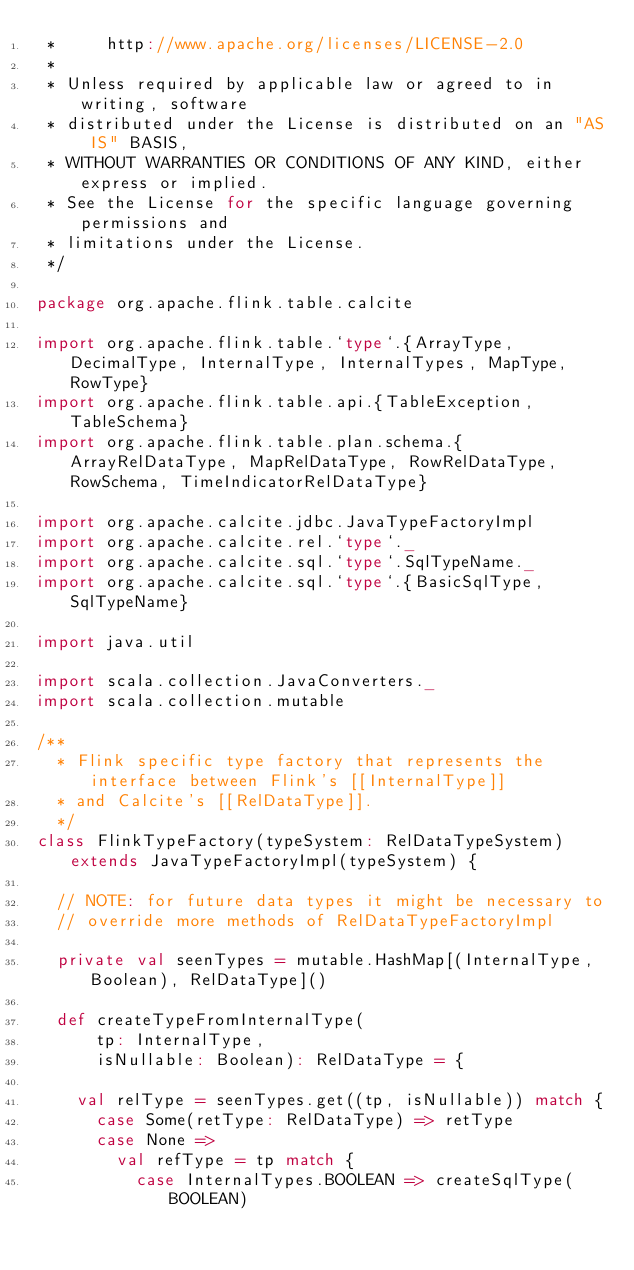<code> <loc_0><loc_0><loc_500><loc_500><_Scala_> *     http://www.apache.org/licenses/LICENSE-2.0
 *
 * Unless required by applicable law or agreed to in writing, software
 * distributed under the License is distributed on an "AS IS" BASIS,
 * WITHOUT WARRANTIES OR CONDITIONS OF ANY KIND, either express or implied.
 * See the License for the specific language governing permissions and
 * limitations under the License.
 */

package org.apache.flink.table.calcite

import org.apache.flink.table.`type`.{ArrayType, DecimalType, InternalType, InternalTypes, MapType, RowType}
import org.apache.flink.table.api.{TableException, TableSchema}
import org.apache.flink.table.plan.schema.{ArrayRelDataType, MapRelDataType, RowRelDataType, RowSchema, TimeIndicatorRelDataType}

import org.apache.calcite.jdbc.JavaTypeFactoryImpl
import org.apache.calcite.rel.`type`._
import org.apache.calcite.sql.`type`.SqlTypeName._
import org.apache.calcite.sql.`type`.{BasicSqlType, SqlTypeName}

import java.util

import scala.collection.JavaConverters._
import scala.collection.mutable

/**
  * Flink specific type factory that represents the interface between Flink's [[InternalType]]
  * and Calcite's [[RelDataType]].
  */
class FlinkTypeFactory(typeSystem: RelDataTypeSystem) extends JavaTypeFactoryImpl(typeSystem) {

  // NOTE: for future data types it might be necessary to
  // override more methods of RelDataTypeFactoryImpl

  private val seenTypes = mutable.HashMap[(InternalType, Boolean), RelDataType]()

  def createTypeFromInternalType(
      tp: InternalType,
      isNullable: Boolean): RelDataType = {

    val relType = seenTypes.get((tp, isNullable)) match {
      case Some(retType: RelDataType) => retType
      case None =>
        val refType = tp match {
          case InternalTypes.BOOLEAN => createSqlType(BOOLEAN)</code> 